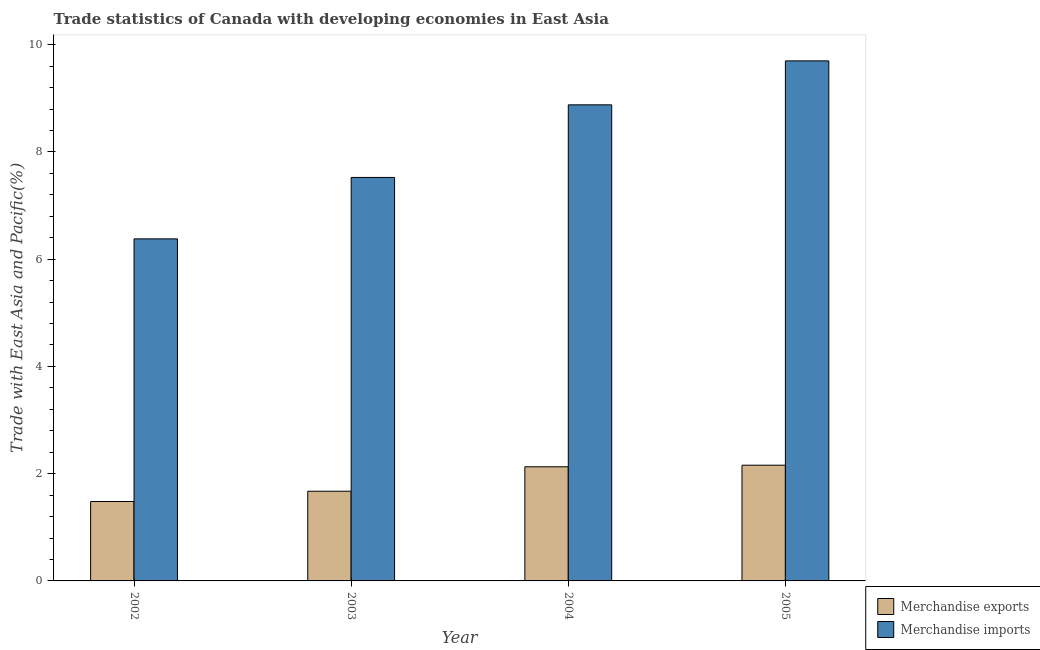Are the number of bars per tick equal to the number of legend labels?
Your answer should be very brief. Yes. How many bars are there on the 2nd tick from the left?
Ensure brevity in your answer.  2. What is the label of the 1st group of bars from the left?
Keep it short and to the point. 2002. In how many cases, is the number of bars for a given year not equal to the number of legend labels?
Your answer should be compact. 0. What is the merchandise exports in 2002?
Offer a very short reply. 1.48. Across all years, what is the maximum merchandise exports?
Give a very brief answer. 2.16. Across all years, what is the minimum merchandise imports?
Keep it short and to the point. 6.38. In which year was the merchandise exports minimum?
Your answer should be compact. 2002. What is the total merchandise imports in the graph?
Make the answer very short. 32.48. What is the difference between the merchandise imports in 2002 and that in 2003?
Ensure brevity in your answer.  -1.15. What is the difference between the merchandise imports in 2003 and the merchandise exports in 2004?
Offer a very short reply. -1.35. What is the average merchandise imports per year?
Ensure brevity in your answer.  8.12. In the year 2003, what is the difference between the merchandise imports and merchandise exports?
Keep it short and to the point. 0. What is the ratio of the merchandise imports in 2002 to that in 2004?
Offer a very short reply. 0.72. Is the merchandise exports in 2002 less than that in 2004?
Offer a terse response. Yes. Is the difference between the merchandise imports in 2004 and 2005 greater than the difference between the merchandise exports in 2004 and 2005?
Ensure brevity in your answer.  No. What is the difference between the highest and the second highest merchandise exports?
Your response must be concise. 0.03. What is the difference between the highest and the lowest merchandise imports?
Ensure brevity in your answer.  3.32. Is the sum of the merchandise exports in 2004 and 2005 greater than the maximum merchandise imports across all years?
Provide a succinct answer. Yes. What does the 2nd bar from the left in 2004 represents?
Provide a succinct answer. Merchandise imports. What does the 1st bar from the right in 2004 represents?
Ensure brevity in your answer.  Merchandise imports. How many bars are there?
Keep it short and to the point. 8. How many years are there in the graph?
Offer a terse response. 4. Does the graph contain any zero values?
Keep it short and to the point. No. Does the graph contain grids?
Offer a very short reply. No. Where does the legend appear in the graph?
Offer a very short reply. Bottom right. How many legend labels are there?
Ensure brevity in your answer.  2. How are the legend labels stacked?
Your response must be concise. Vertical. What is the title of the graph?
Provide a succinct answer. Trade statistics of Canada with developing economies in East Asia. What is the label or title of the Y-axis?
Ensure brevity in your answer.  Trade with East Asia and Pacific(%). What is the Trade with East Asia and Pacific(%) in Merchandise exports in 2002?
Provide a short and direct response. 1.48. What is the Trade with East Asia and Pacific(%) in Merchandise imports in 2002?
Your answer should be very brief. 6.38. What is the Trade with East Asia and Pacific(%) of Merchandise exports in 2003?
Give a very brief answer. 1.67. What is the Trade with East Asia and Pacific(%) in Merchandise imports in 2003?
Offer a terse response. 7.52. What is the Trade with East Asia and Pacific(%) of Merchandise exports in 2004?
Make the answer very short. 2.13. What is the Trade with East Asia and Pacific(%) in Merchandise imports in 2004?
Ensure brevity in your answer.  8.88. What is the Trade with East Asia and Pacific(%) in Merchandise exports in 2005?
Offer a very short reply. 2.16. What is the Trade with East Asia and Pacific(%) of Merchandise imports in 2005?
Make the answer very short. 9.7. Across all years, what is the maximum Trade with East Asia and Pacific(%) of Merchandise exports?
Keep it short and to the point. 2.16. Across all years, what is the maximum Trade with East Asia and Pacific(%) in Merchandise imports?
Your answer should be compact. 9.7. Across all years, what is the minimum Trade with East Asia and Pacific(%) in Merchandise exports?
Provide a short and direct response. 1.48. Across all years, what is the minimum Trade with East Asia and Pacific(%) of Merchandise imports?
Your answer should be very brief. 6.38. What is the total Trade with East Asia and Pacific(%) in Merchandise exports in the graph?
Provide a short and direct response. 7.44. What is the total Trade with East Asia and Pacific(%) in Merchandise imports in the graph?
Offer a terse response. 32.48. What is the difference between the Trade with East Asia and Pacific(%) of Merchandise exports in 2002 and that in 2003?
Offer a very short reply. -0.19. What is the difference between the Trade with East Asia and Pacific(%) in Merchandise imports in 2002 and that in 2003?
Your response must be concise. -1.15. What is the difference between the Trade with East Asia and Pacific(%) in Merchandise exports in 2002 and that in 2004?
Your answer should be very brief. -0.65. What is the difference between the Trade with East Asia and Pacific(%) in Merchandise imports in 2002 and that in 2004?
Offer a terse response. -2.5. What is the difference between the Trade with East Asia and Pacific(%) in Merchandise exports in 2002 and that in 2005?
Your answer should be very brief. -0.68. What is the difference between the Trade with East Asia and Pacific(%) in Merchandise imports in 2002 and that in 2005?
Offer a terse response. -3.32. What is the difference between the Trade with East Asia and Pacific(%) of Merchandise exports in 2003 and that in 2004?
Offer a terse response. -0.46. What is the difference between the Trade with East Asia and Pacific(%) of Merchandise imports in 2003 and that in 2004?
Provide a short and direct response. -1.35. What is the difference between the Trade with East Asia and Pacific(%) of Merchandise exports in 2003 and that in 2005?
Make the answer very short. -0.49. What is the difference between the Trade with East Asia and Pacific(%) of Merchandise imports in 2003 and that in 2005?
Your answer should be very brief. -2.17. What is the difference between the Trade with East Asia and Pacific(%) of Merchandise exports in 2004 and that in 2005?
Provide a succinct answer. -0.03. What is the difference between the Trade with East Asia and Pacific(%) in Merchandise imports in 2004 and that in 2005?
Your response must be concise. -0.82. What is the difference between the Trade with East Asia and Pacific(%) in Merchandise exports in 2002 and the Trade with East Asia and Pacific(%) in Merchandise imports in 2003?
Make the answer very short. -6.04. What is the difference between the Trade with East Asia and Pacific(%) in Merchandise exports in 2002 and the Trade with East Asia and Pacific(%) in Merchandise imports in 2004?
Give a very brief answer. -7.4. What is the difference between the Trade with East Asia and Pacific(%) of Merchandise exports in 2002 and the Trade with East Asia and Pacific(%) of Merchandise imports in 2005?
Your response must be concise. -8.22. What is the difference between the Trade with East Asia and Pacific(%) of Merchandise exports in 2003 and the Trade with East Asia and Pacific(%) of Merchandise imports in 2004?
Offer a terse response. -7.21. What is the difference between the Trade with East Asia and Pacific(%) in Merchandise exports in 2003 and the Trade with East Asia and Pacific(%) in Merchandise imports in 2005?
Your answer should be very brief. -8.03. What is the difference between the Trade with East Asia and Pacific(%) in Merchandise exports in 2004 and the Trade with East Asia and Pacific(%) in Merchandise imports in 2005?
Ensure brevity in your answer.  -7.57. What is the average Trade with East Asia and Pacific(%) of Merchandise exports per year?
Your response must be concise. 1.86. What is the average Trade with East Asia and Pacific(%) of Merchandise imports per year?
Provide a succinct answer. 8.12. In the year 2002, what is the difference between the Trade with East Asia and Pacific(%) in Merchandise exports and Trade with East Asia and Pacific(%) in Merchandise imports?
Offer a very short reply. -4.9. In the year 2003, what is the difference between the Trade with East Asia and Pacific(%) of Merchandise exports and Trade with East Asia and Pacific(%) of Merchandise imports?
Provide a short and direct response. -5.85. In the year 2004, what is the difference between the Trade with East Asia and Pacific(%) of Merchandise exports and Trade with East Asia and Pacific(%) of Merchandise imports?
Give a very brief answer. -6.75. In the year 2005, what is the difference between the Trade with East Asia and Pacific(%) of Merchandise exports and Trade with East Asia and Pacific(%) of Merchandise imports?
Provide a short and direct response. -7.54. What is the ratio of the Trade with East Asia and Pacific(%) in Merchandise exports in 2002 to that in 2003?
Give a very brief answer. 0.89. What is the ratio of the Trade with East Asia and Pacific(%) in Merchandise imports in 2002 to that in 2003?
Your answer should be very brief. 0.85. What is the ratio of the Trade with East Asia and Pacific(%) in Merchandise exports in 2002 to that in 2004?
Your response must be concise. 0.7. What is the ratio of the Trade with East Asia and Pacific(%) of Merchandise imports in 2002 to that in 2004?
Offer a terse response. 0.72. What is the ratio of the Trade with East Asia and Pacific(%) in Merchandise exports in 2002 to that in 2005?
Ensure brevity in your answer.  0.69. What is the ratio of the Trade with East Asia and Pacific(%) in Merchandise imports in 2002 to that in 2005?
Your answer should be compact. 0.66. What is the ratio of the Trade with East Asia and Pacific(%) in Merchandise exports in 2003 to that in 2004?
Make the answer very short. 0.79. What is the ratio of the Trade with East Asia and Pacific(%) of Merchandise imports in 2003 to that in 2004?
Offer a very short reply. 0.85. What is the ratio of the Trade with East Asia and Pacific(%) in Merchandise exports in 2003 to that in 2005?
Provide a succinct answer. 0.78. What is the ratio of the Trade with East Asia and Pacific(%) in Merchandise imports in 2003 to that in 2005?
Offer a very short reply. 0.78. What is the ratio of the Trade with East Asia and Pacific(%) in Merchandise exports in 2004 to that in 2005?
Keep it short and to the point. 0.99. What is the ratio of the Trade with East Asia and Pacific(%) of Merchandise imports in 2004 to that in 2005?
Ensure brevity in your answer.  0.92. What is the difference between the highest and the second highest Trade with East Asia and Pacific(%) in Merchandise exports?
Make the answer very short. 0.03. What is the difference between the highest and the second highest Trade with East Asia and Pacific(%) of Merchandise imports?
Provide a succinct answer. 0.82. What is the difference between the highest and the lowest Trade with East Asia and Pacific(%) in Merchandise exports?
Provide a succinct answer. 0.68. What is the difference between the highest and the lowest Trade with East Asia and Pacific(%) of Merchandise imports?
Provide a succinct answer. 3.32. 